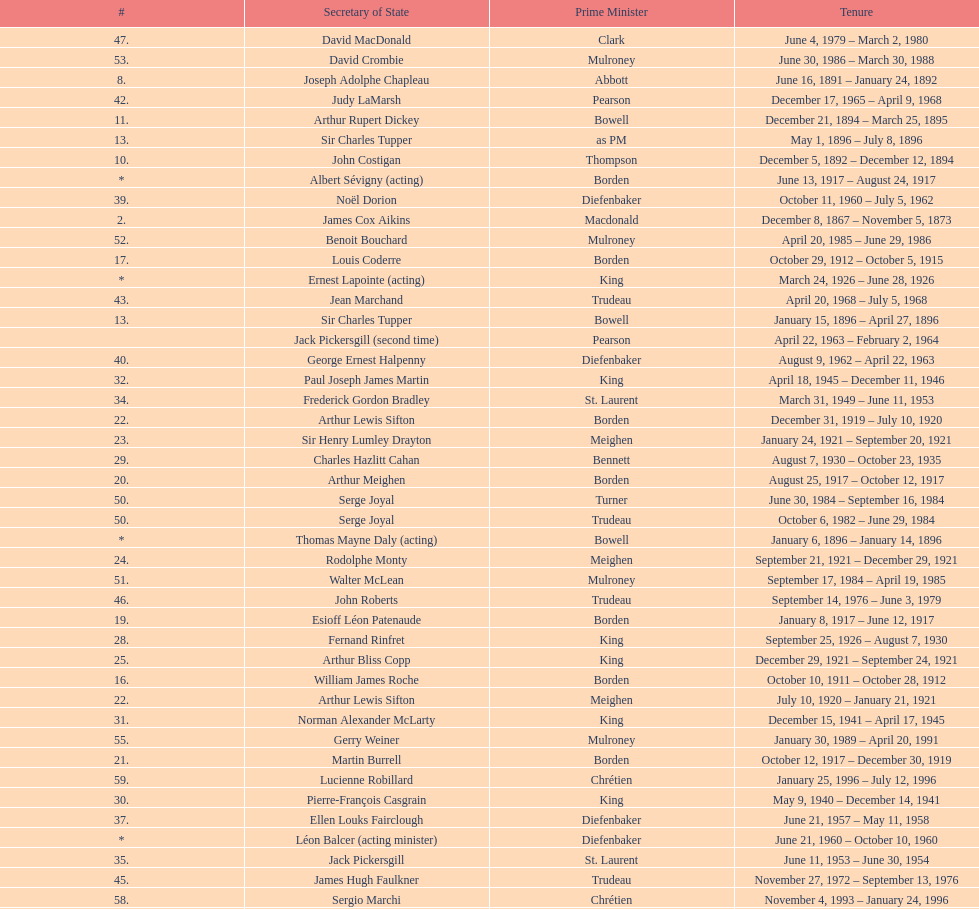How many secretaries of state had the last name bouchard? 2. 